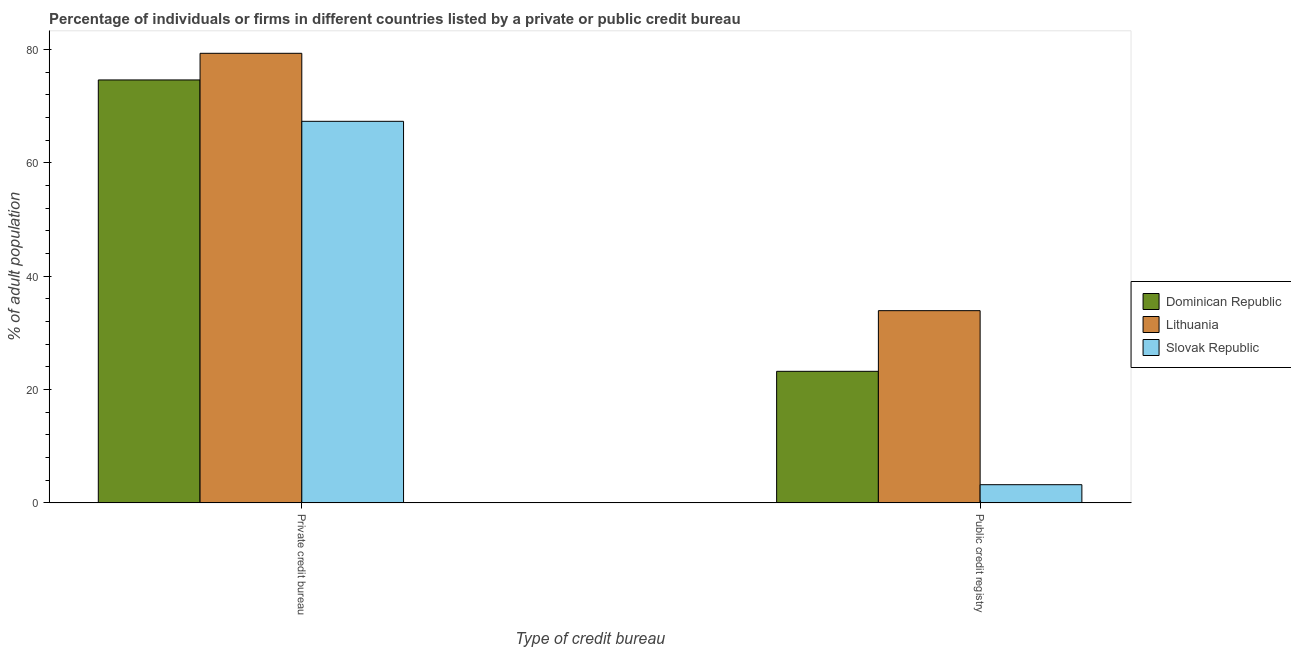Are the number of bars on each tick of the X-axis equal?
Give a very brief answer. Yes. How many bars are there on the 2nd tick from the left?
Provide a short and direct response. 3. What is the label of the 2nd group of bars from the left?
Provide a short and direct response. Public credit registry. What is the percentage of firms listed by private credit bureau in Lithuania?
Ensure brevity in your answer.  79.3. Across all countries, what is the maximum percentage of firms listed by private credit bureau?
Your response must be concise. 79.3. Across all countries, what is the minimum percentage of firms listed by private credit bureau?
Provide a short and direct response. 67.3. In which country was the percentage of firms listed by private credit bureau maximum?
Offer a very short reply. Lithuania. In which country was the percentage of firms listed by private credit bureau minimum?
Your answer should be compact. Slovak Republic. What is the total percentage of firms listed by public credit bureau in the graph?
Provide a succinct answer. 60.3. What is the difference between the percentage of firms listed by private credit bureau in Lithuania and that in Dominican Republic?
Offer a terse response. 4.7. What is the difference between the percentage of firms listed by private credit bureau in Lithuania and the percentage of firms listed by public credit bureau in Slovak Republic?
Keep it short and to the point. 76.1. What is the average percentage of firms listed by public credit bureau per country?
Offer a very short reply. 20.1. What is the difference between the percentage of firms listed by private credit bureau and percentage of firms listed by public credit bureau in Lithuania?
Your answer should be very brief. 45.4. What is the ratio of the percentage of firms listed by private credit bureau in Dominican Republic to that in Slovak Republic?
Provide a short and direct response. 1.11. What does the 3rd bar from the left in Private credit bureau represents?
Your answer should be very brief. Slovak Republic. What does the 2nd bar from the right in Public credit registry represents?
Offer a very short reply. Lithuania. Are all the bars in the graph horizontal?
Make the answer very short. No. How many countries are there in the graph?
Offer a very short reply. 3. What is the difference between two consecutive major ticks on the Y-axis?
Ensure brevity in your answer.  20. Are the values on the major ticks of Y-axis written in scientific E-notation?
Offer a very short reply. No. Where does the legend appear in the graph?
Your answer should be very brief. Center right. How many legend labels are there?
Your response must be concise. 3. How are the legend labels stacked?
Provide a short and direct response. Vertical. What is the title of the graph?
Keep it short and to the point. Percentage of individuals or firms in different countries listed by a private or public credit bureau. Does "Monaco" appear as one of the legend labels in the graph?
Keep it short and to the point. No. What is the label or title of the X-axis?
Offer a very short reply. Type of credit bureau. What is the label or title of the Y-axis?
Offer a very short reply. % of adult population. What is the % of adult population in Dominican Republic in Private credit bureau?
Provide a succinct answer. 74.6. What is the % of adult population in Lithuania in Private credit bureau?
Ensure brevity in your answer.  79.3. What is the % of adult population of Slovak Republic in Private credit bureau?
Make the answer very short. 67.3. What is the % of adult population in Dominican Republic in Public credit registry?
Provide a short and direct response. 23.2. What is the % of adult population in Lithuania in Public credit registry?
Your answer should be very brief. 33.9. Across all Type of credit bureau, what is the maximum % of adult population in Dominican Republic?
Give a very brief answer. 74.6. Across all Type of credit bureau, what is the maximum % of adult population of Lithuania?
Offer a terse response. 79.3. Across all Type of credit bureau, what is the maximum % of adult population of Slovak Republic?
Offer a terse response. 67.3. Across all Type of credit bureau, what is the minimum % of adult population of Dominican Republic?
Offer a very short reply. 23.2. Across all Type of credit bureau, what is the minimum % of adult population in Lithuania?
Your response must be concise. 33.9. What is the total % of adult population of Dominican Republic in the graph?
Offer a terse response. 97.8. What is the total % of adult population of Lithuania in the graph?
Offer a terse response. 113.2. What is the total % of adult population of Slovak Republic in the graph?
Your answer should be very brief. 70.5. What is the difference between the % of adult population of Dominican Republic in Private credit bureau and that in Public credit registry?
Your answer should be compact. 51.4. What is the difference between the % of adult population in Lithuania in Private credit bureau and that in Public credit registry?
Your response must be concise. 45.4. What is the difference between the % of adult population of Slovak Republic in Private credit bureau and that in Public credit registry?
Offer a very short reply. 64.1. What is the difference between the % of adult population of Dominican Republic in Private credit bureau and the % of adult population of Lithuania in Public credit registry?
Offer a terse response. 40.7. What is the difference between the % of adult population of Dominican Republic in Private credit bureau and the % of adult population of Slovak Republic in Public credit registry?
Ensure brevity in your answer.  71.4. What is the difference between the % of adult population of Lithuania in Private credit bureau and the % of adult population of Slovak Republic in Public credit registry?
Offer a very short reply. 76.1. What is the average % of adult population in Dominican Republic per Type of credit bureau?
Provide a short and direct response. 48.9. What is the average % of adult population of Lithuania per Type of credit bureau?
Ensure brevity in your answer.  56.6. What is the average % of adult population in Slovak Republic per Type of credit bureau?
Provide a succinct answer. 35.25. What is the difference between the % of adult population in Lithuania and % of adult population in Slovak Republic in Public credit registry?
Provide a succinct answer. 30.7. What is the ratio of the % of adult population in Dominican Republic in Private credit bureau to that in Public credit registry?
Keep it short and to the point. 3.22. What is the ratio of the % of adult population of Lithuania in Private credit bureau to that in Public credit registry?
Provide a succinct answer. 2.34. What is the ratio of the % of adult population of Slovak Republic in Private credit bureau to that in Public credit registry?
Your response must be concise. 21.03. What is the difference between the highest and the second highest % of adult population of Dominican Republic?
Provide a succinct answer. 51.4. What is the difference between the highest and the second highest % of adult population of Lithuania?
Your answer should be very brief. 45.4. What is the difference between the highest and the second highest % of adult population of Slovak Republic?
Offer a terse response. 64.1. What is the difference between the highest and the lowest % of adult population in Dominican Republic?
Offer a terse response. 51.4. What is the difference between the highest and the lowest % of adult population in Lithuania?
Your answer should be compact. 45.4. What is the difference between the highest and the lowest % of adult population in Slovak Republic?
Offer a very short reply. 64.1. 